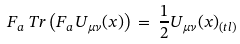<formula> <loc_0><loc_0><loc_500><loc_500>F _ { a } \, T r \left ( F _ { a } U _ { \mu \nu } ( x ) \right ) \, = \, \frac { 1 } { 2 } U _ { \mu \nu } ( x ) _ { ( t l ) }</formula> 